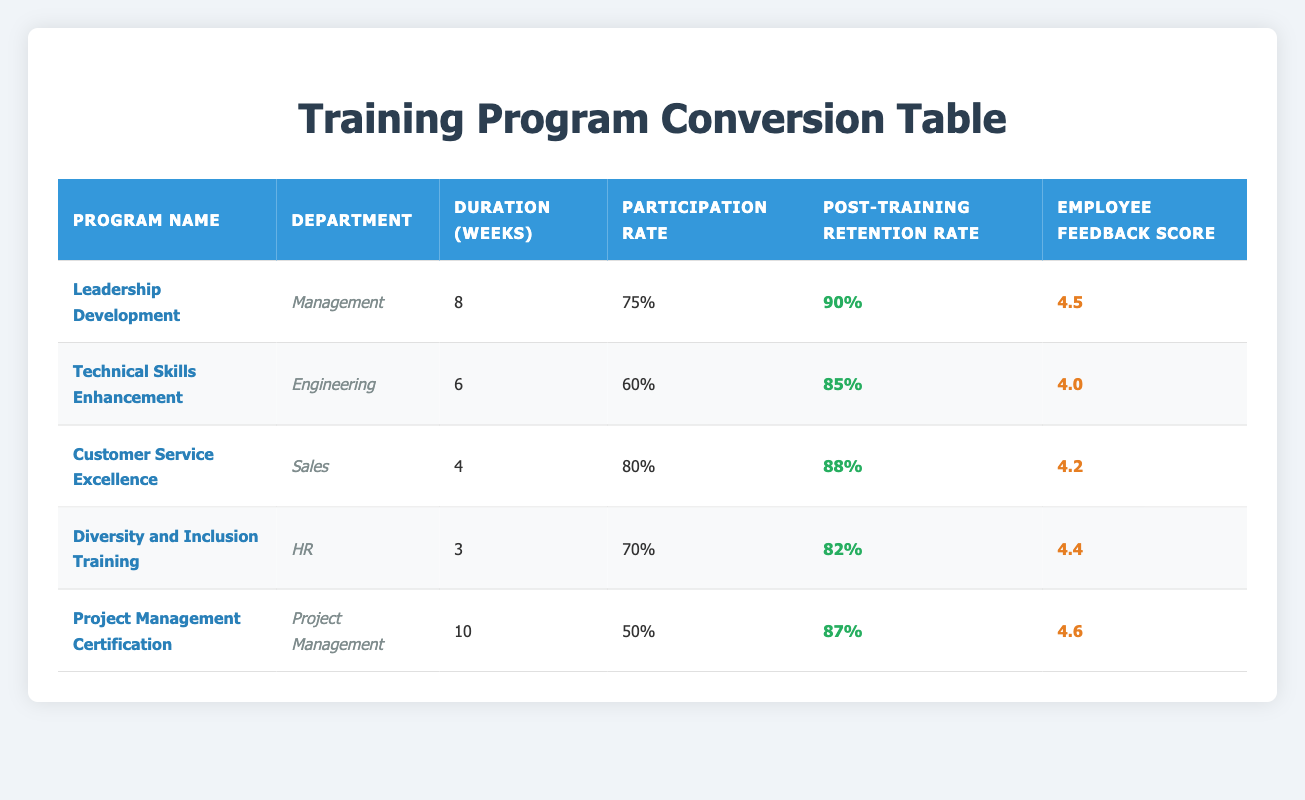What is the participation rate of the "Customer Service Excellence" program? The participation rate for the "Customer Service Excellence" program is listed in the table under the Participation Rate column. It shows 80%.
Answer: 80% Which training program has the highest post-training retention rate? To find this, we need to look at the Post-Training Retention Rate column and identify the highest value. The "Leadership Development" program has a retention rate of 90%, which is the highest.
Answer: Leadership Development What is the average duration of all training programs? We can sum the durations of all programs: 8 + 6 + 4 + 3 + 10 = 31 weeks. There are 5 programs, so the average duration is 31 / 5 = 6.2 weeks.
Answer: 6.2 weeks Is the employee feedback score for the "Project Management Certification" higher than the score for the "Technical Skills Enhancement"? The feedback score for "Project Management Certification" is 4.6 and for "Technical Skills Enhancement" is 4.0. Since 4.6 is greater than 4.0, the statement is true.
Answer: Yes Which department has the lowest participation rate across all programs? We compare the participation rates of each program per department. "Project Management" has the lowest participation rate at 50%.
Answer: Project Management What is the total of post-training retention rates for all training programs? We will add the post-training retention rates: 90 + 85 + 88 + 82 + 87 = 432%. To get the total, it sums up to 432%.
Answer: 432% Does the "Diversity and Inclusion Training" program have a feedback score lower than 4.5? The feedback score for "Diversity and Inclusion Training" is 4.4, which is lower than 4.5. Thus the answer is yes.
Answer: Yes Which program with duration greater than 5 weeks has a post-training retention rate less than 90%? The "Technical Skills Enhancement" and "Project Management Certification" programs both exceed 5 weeks. Their retention rates are 85% and 87%, respectively, which are less than 90%. The answer includes both programs.
Answer: Technical Skills Enhancement, Project Management Certification What is the maximum employee feedback score achieved for any program? Checking the Employee Feedback Score column, we see that the "Project Management Certification" has the highest score of 4.6.
Answer: 4.6 